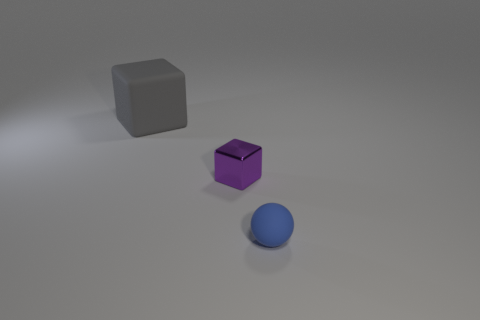Is the number of gray cubes that are on the left side of the small purple cube less than the number of things behind the blue thing?
Offer a very short reply. Yes. Do the large rubber cube and the tiny rubber thing have the same color?
Give a very brief answer. No. Are there fewer tiny purple objects that are left of the small metallic block than purple things?
Keep it short and to the point. Yes. Is the small ball made of the same material as the large gray thing?
Offer a terse response. Yes. How many purple objects are made of the same material as the sphere?
Keep it short and to the point. 0. The tiny thing that is the same material as the big thing is what color?
Offer a terse response. Blue. There is a tiny blue rubber object; what shape is it?
Your answer should be compact. Sphere. What is the block that is left of the tiny block made of?
Your answer should be very brief. Rubber. Is there a matte cube that has the same color as the tiny metal cube?
Keep it short and to the point. No. What is the shape of the blue rubber thing that is the same size as the purple metal thing?
Ensure brevity in your answer.  Sphere. 